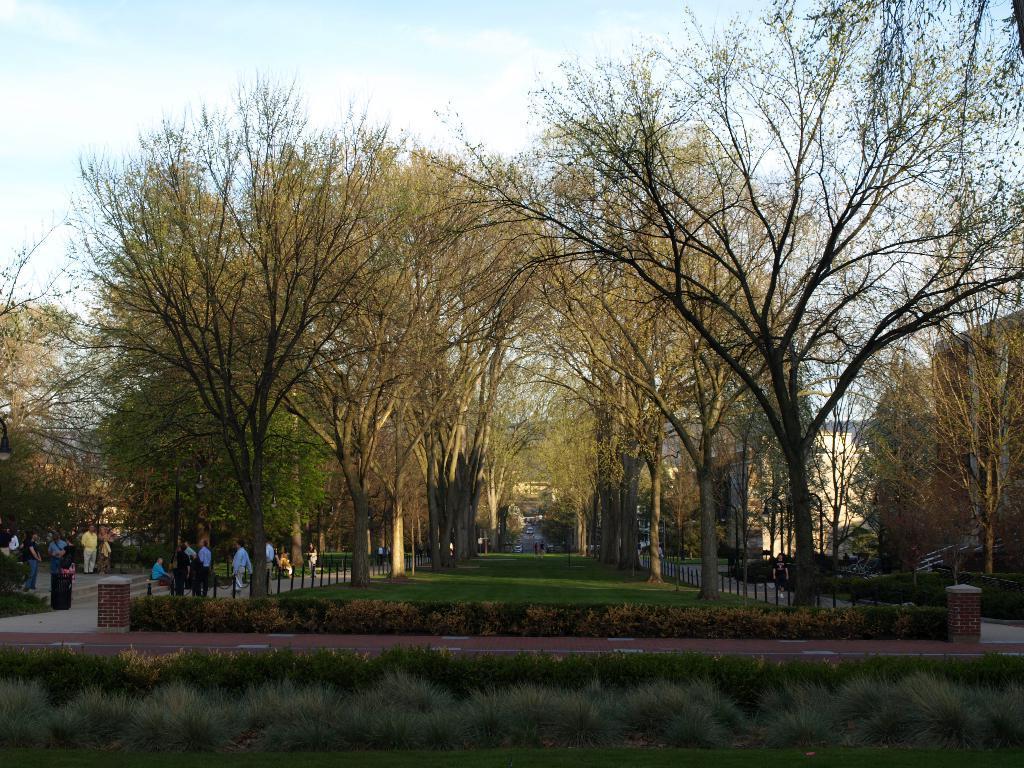How would you summarize this image in a sentence or two? There are plants at the bottom of this image. We can see a group of people and trees in the middle of this image. The cloudy sky is at the top of this image. 